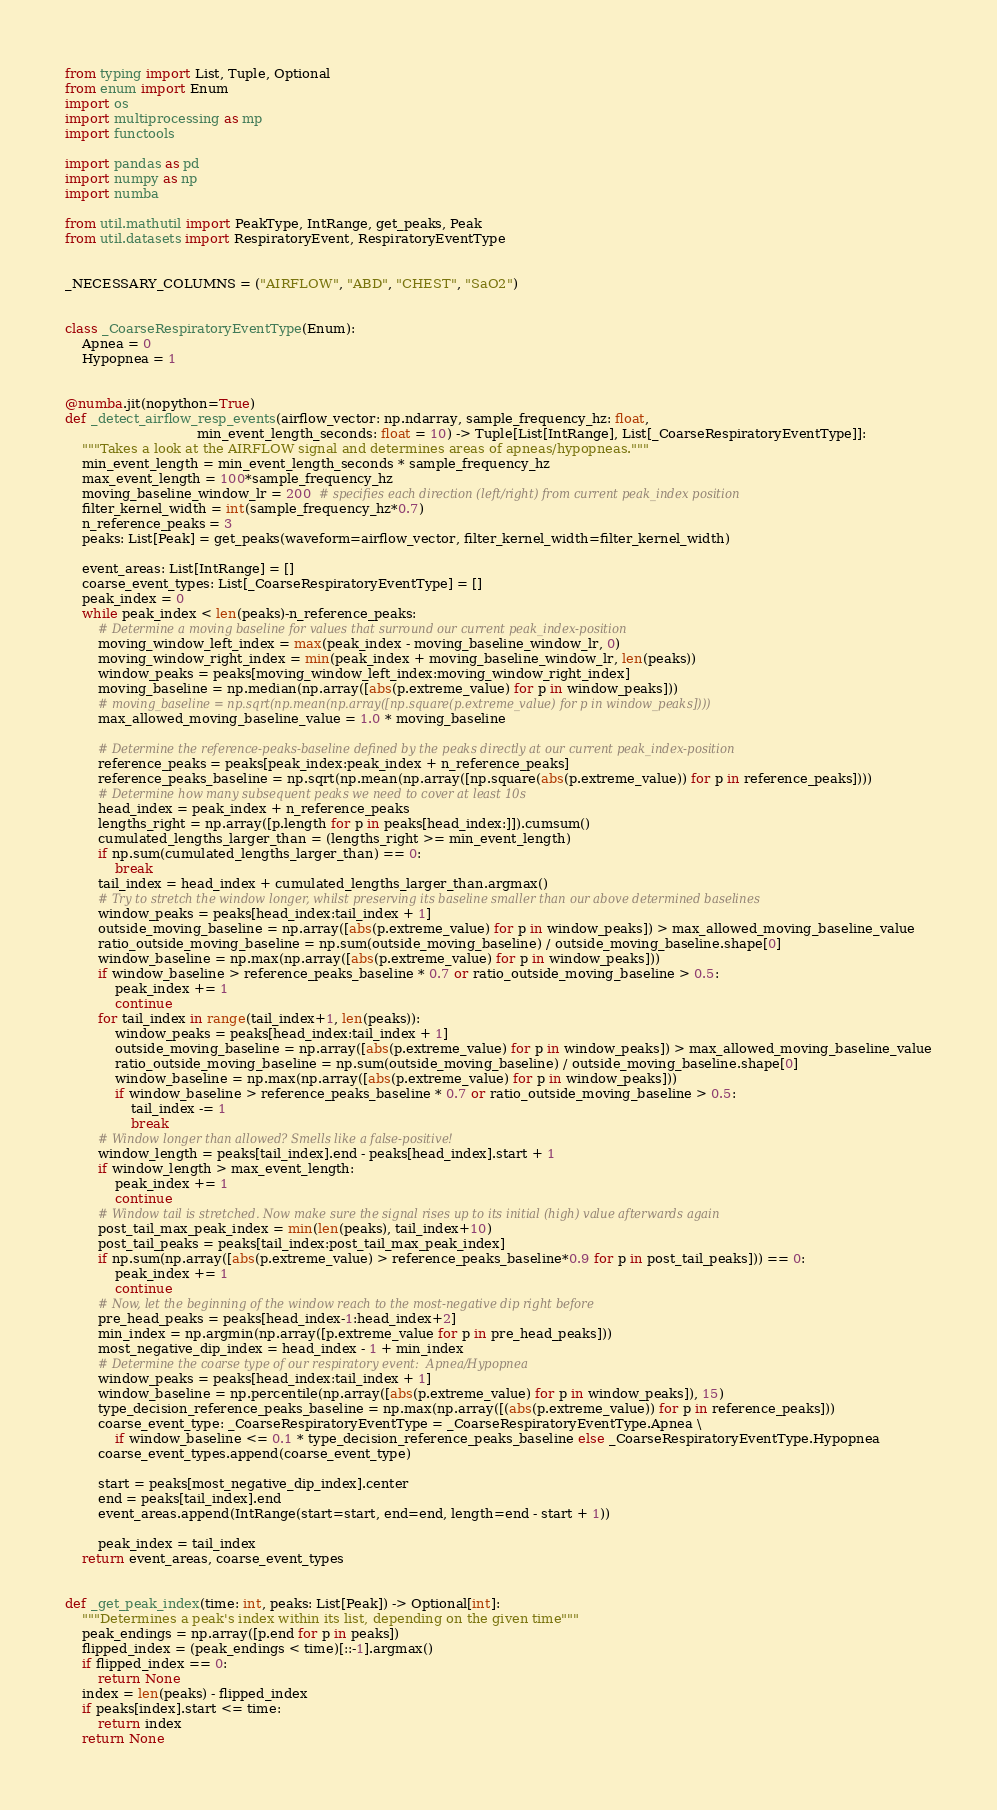Convert code to text. <code><loc_0><loc_0><loc_500><loc_500><_Python_>from typing import List, Tuple, Optional
from enum import Enum
import os
import multiprocessing as mp
import functools

import pandas as pd
import numpy as np
import numba

from util.mathutil import PeakType, IntRange, get_peaks, Peak
from util.datasets import RespiratoryEvent, RespiratoryEventType


_NECESSARY_COLUMNS = ("AIRFLOW", "ABD", "CHEST", "SaO2")


class _CoarseRespiratoryEventType(Enum):
    Apnea = 0
    Hypopnea = 1


@numba.jit(nopython=True)
def _detect_airflow_resp_events(airflow_vector: np.ndarray, sample_frequency_hz: float,
                                min_event_length_seconds: float = 10) -> Tuple[List[IntRange], List[_CoarseRespiratoryEventType]]:
    """Takes a look at the AIRFLOW signal and determines areas of apneas/hypopneas."""
    min_event_length = min_event_length_seconds * sample_frequency_hz
    max_event_length = 100*sample_frequency_hz
    moving_baseline_window_lr = 200  # specifies each direction (left/right) from current peak_index position
    filter_kernel_width = int(sample_frequency_hz*0.7)
    n_reference_peaks = 3
    peaks: List[Peak] = get_peaks(waveform=airflow_vector, filter_kernel_width=filter_kernel_width)

    event_areas: List[IntRange] = []
    coarse_event_types: List[_CoarseRespiratoryEventType] = []
    peak_index = 0
    while peak_index < len(peaks)-n_reference_peaks:
        # Determine a moving baseline for values that surround our current peak_index-position
        moving_window_left_index = max(peak_index - moving_baseline_window_lr, 0)
        moving_window_right_index = min(peak_index + moving_baseline_window_lr, len(peaks))
        window_peaks = peaks[moving_window_left_index:moving_window_right_index]
        moving_baseline = np.median(np.array([abs(p.extreme_value) for p in window_peaks]))
        # moving_baseline = np.sqrt(np.mean(np.array([np.square(p.extreme_value) for p in window_peaks])))
        max_allowed_moving_baseline_value = 1.0 * moving_baseline

        # Determine the reference-peaks-baseline defined by the peaks directly at our current peak_index-position
        reference_peaks = peaks[peak_index:peak_index + n_reference_peaks]
        reference_peaks_baseline = np.sqrt(np.mean(np.array([np.square(abs(p.extreme_value)) for p in reference_peaks])))
        # Determine how many subsequent peaks we need to cover at least 10s
        head_index = peak_index + n_reference_peaks
        lengths_right = np.array([p.length for p in peaks[head_index:]]).cumsum()
        cumulated_lengths_larger_than = (lengths_right >= min_event_length)
        if np.sum(cumulated_lengths_larger_than) == 0:
            break
        tail_index = head_index + cumulated_lengths_larger_than.argmax()
        # Try to stretch the window longer, whilst preserving its baseline smaller than our above determined baselines
        window_peaks = peaks[head_index:tail_index + 1]
        outside_moving_baseline = np.array([abs(p.extreme_value) for p in window_peaks]) > max_allowed_moving_baseline_value
        ratio_outside_moving_baseline = np.sum(outside_moving_baseline) / outside_moving_baseline.shape[0]
        window_baseline = np.max(np.array([abs(p.extreme_value) for p in window_peaks]))
        if window_baseline > reference_peaks_baseline * 0.7 or ratio_outside_moving_baseline > 0.5:
            peak_index += 1
            continue
        for tail_index in range(tail_index+1, len(peaks)):
            window_peaks = peaks[head_index:tail_index + 1]
            outside_moving_baseline = np.array([abs(p.extreme_value) for p in window_peaks]) > max_allowed_moving_baseline_value
            ratio_outside_moving_baseline = np.sum(outside_moving_baseline) / outside_moving_baseline.shape[0]
            window_baseline = np.max(np.array([abs(p.extreme_value) for p in window_peaks]))
            if window_baseline > reference_peaks_baseline * 0.7 or ratio_outside_moving_baseline > 0.5:
                tail_index -= 1
                break
        # Window longer than allowed? Smells like a false-positive!
        window_length = peaks[tail_index].end - peaks[head_index].start + 1
        if window_length > max_event_length:
            peak_index += 1
            continue
        # Window tail is stretched. Now make sure the signal rises up to its initial (high) value afterwards again
        post_tail_max_peak_index = min(len(peaks), tail_index+10)
        post_tail_peaks = peaks[tail_index:post_tail_max_peak_index]
        if np.sum(np.array([abs(p.extreme_value) > reference_peaks_baseline*0.9 for p in post_tail_peaks])) == 0:
            peak_index += 1
            continue
        # Now, let the beginning of the window reach to the most-negative dip right before
        pre_head_peaks = peaks[head_index-1:head_index+2]
        min_index = np.argmin(np.array([p.extreme_value for p in pre_head_peaks]))
        most_negative_dip_index = head_index - 1 + min_index
        # Determine the coarse type of our respiratory event:  Apnea/Hypopnea
        window_peaks = peaks[head_index:tail_index + 1]
        window_baseline = np.percentile(np.array([abs(p.extreme_value) for p in window_peaks]), 15)
        type_decision_reference_peaks_baseline = np.max(np.array([(abs(p.extreme_value)) for p in reference_peaks]))
        coarse_event_type: _CoarseRespiratoryEventType = _CoarseRespiratoryEventType.Apnea \
            if window_baseline <= 0.1 * type_decision_reference_peaks_baseline else _CoarseRespiratoryEventType.Hypopnea
        coarse_event_types.append(coarse_event_type)

        start = peaks[most_negative_dip_index].center
        end = peaks[tail_index].end
        event_areas.append(IntRange(start=start, end=end, length=end - start + 1))

        peak_index = tail_index
    return event_areas, coarse_event_types


def _get_peak_index(time: int, peaks: List[Peak]) -> Optional[int]:
    """Determines a peak's index within its list, depending on the given time"""
    peak_endings = np.array([p.end for p in peaks])
    flipped_index = (peak_endings < time)[::-1].argmax()
    if flipped_index == 0:
        return None
    index = len(peaks) - flipped_index
    if peaks[index].start <= time:
        return index
    return None

</code> 